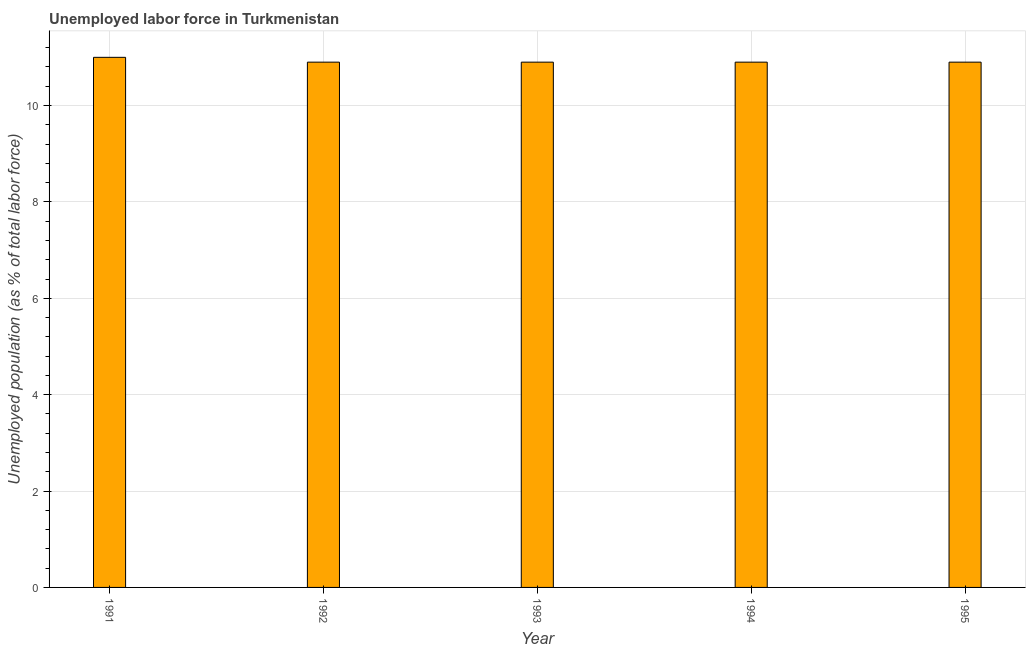Does the graph contain grids?
Your response must be concise. Yes. What is the title of the graph?
Provide a short and direct response. Unemployed labor force in Turkmenistan. What is the label or title of the X-axis?
Keep it short and to the point. Year. What is the label or title of the Y-axis?
Offer a very short reply. Unemployed population (as % of total labor force). What is the total unemployed population in 1993?
Keep it short and to the point. 10.9. Across all years, what is the maximum total unemployed population?
Your answer should be compact. 11. Across all years, what is the minimum total unemployed population?
Offer a terse response. 10.9. In which year was the total unemployed population maximum?
Keep it short and to the point. 1991. In which year was the total unemployed population minimum?
Ensure brevity in your answer.  1992. What is the sum of the total unemployed population?
Your response must be concise. 54.6. What is the difference between the total unemployed population in 1993 and 1995?
Your response must be concise. 0. What is the average total unemployed population per year?
Make the answer very short. 10.92. What is the median total unemployed population?
Make the answer very short. 10.9. Do a majority of the years between 1991 and 1993 (inclusive) have total unemployed population greater than 0.8 %?
Provide a succinct answer. Yes. What is the ratio of the total unemployed population in 1993 to that in 1995?
Provide a succinct answer. 1. Is the difference between the total unemployed population in 1992 and 1995 greater than the difference between any two years?
Your answer should be compact. No. What is the difference between the highest and the lowest total unemployed population?
Offer a terse response. 0.1. How many bars are there?
Offer a very short reply. 5. Are all the bars in the graph horizontal?
Keep it short and to the point. No. Are the values on the major ticks of Y-axis written in scientific E-notation?
Your answer should be compact. No. What is the Unemployed population (as % of total labor force) in 1991?
Offer a very short reply. 11. What is the Unemployed population (as % of total labor force) in 1992?
Provide a succinct answer. 10.9. What is the Unemployed population (as % of total labor force) in 1993?
Offer a terse response. 10.9. What is the Unemployed population (as % of total labor force) of 1994?
Make the answer very short. 10.9. What is the Unemployed population (as % of total labor force) in 1995?
Ensure brevity in your answer.  10.9. What is the difference between the Unemployed population (as % of total labor force) in 1991 and 1993?
Your answer should be compact. 0.1. What is the difference between the Unemployed population (as % of total labor force) in 1991 and 1994?
Your answer should be very brief. 0.1. What is the difference between the Unemployed population (as % of total labor force) in 1993 and 1994?
Ensure brevity in your answer.  0. What is the difference between the Unemployed population (as % of total labor force) in 1994 and 1995?
Offer a terse response. 0. What is the ratio of the Unemployed population (as % of total labor force) in 1991 to that in 1992?
Make the answer very short. 1.01. What is the ratio of the Unemployed population (as % of total labor force) in 1991 to that in 1994?
Provide a succinct answer. 1.01. What is the ratio of the Unemployed population (as % of total labor force) in 1991 to that in 1995?
Keep it short and to the point. 1.01. What is the ratio of the Unemployed population (as % of total labor force) in 1992 to that in 1993?
Your answer should be compact. 1. What is the ratio of the Unemployed population (as % of total labor force) in 1992 to that in 1994?
Your answer should be compact. 1. What is the ratio of the Unemployed population (as % of total labor force) in 1992 to that in 1995?
Your answer should be compact. 1. What is the ratio of the Unemployed population (as % of total labor force) in 1993 to that in 1994?
Make the answer very short. 1. What is the ratio of the Unemployed population (as % of total labor force) in 1993 to that in 1995?
Your answer should be compact. 1. What is the ratio of the Unemployed population (as % of total labor force) in 1994 to that in 1995?
Your answer should be very brief. 1. 